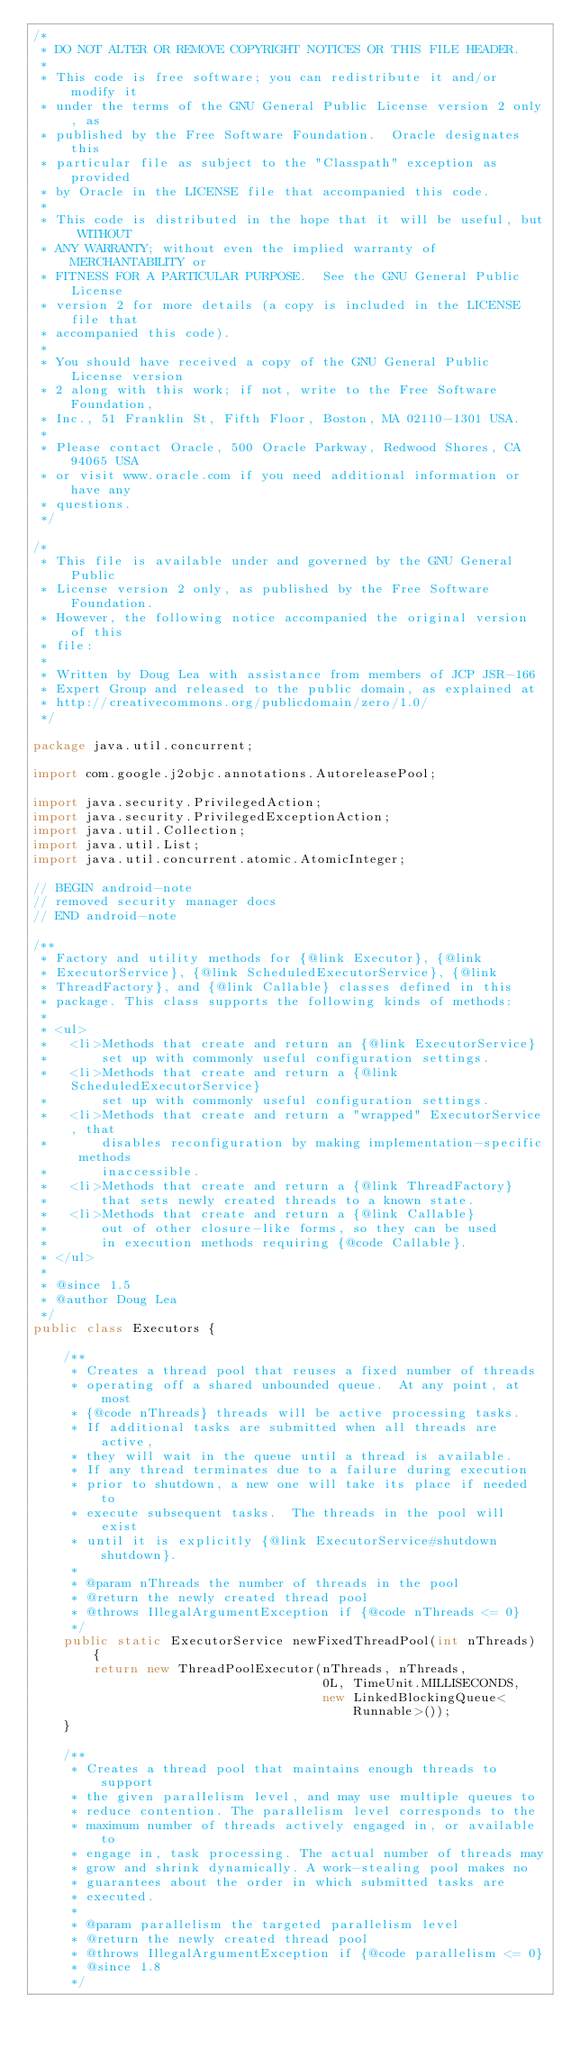Convert code to text. <code><loc_0><loc_0><loc_500><loc_500><_Java_>/*
 * DO NOT ALTER OR REMOVE COPYRIGHT NOTICES OR THIS FILE HEADER.
 *
 * This code is free software; you can redistribute it and/or modify it
 * under the terms of the GNU General Public License version 2 only, as
 * published by the Free Software Foundation.  Oracle designates this
 * particular file as subject to the "Classpath" exception as provided
 * by Oracle in the LICENSE file that accompanied this code.
 *
 * This code is distributed in the hope that it will be useful, but WITHOUT
 * ANY WARRANTY; without even the implied warranty of MERCHANTABILITY or
 * FITNESS FOR A PARTICULAR PURPOSE.  See the GNU General Public License
 * version 2 for more details (a copy is included in the LICENSE file that
 * accompanied this code).
 *
 * You should have received a copy of the GNU General Public License version
 * 2 along with this work; if not, write to the Free Software Foundation,
 * Inc., 51 Franklin St, Fifth Floor, Boston, MA 02110-1301 USA.
 *
 * Please contact Oracle, 500 Oracle Parkway, Redwood Shores, CA 94065 USA
 * or visit www.oracle.com if you need additional information or have any
 * questions.
 */

/*
 * This file is available under and governed by the GNU General Public
 * License version 2 only, as published by the Free Software Foundation.
 * However, the following notice accompanied the original version of this
 * file:
 *
 * Written by Doug Lea with assistance from members of JCP JSR-166
 * Expert Group and released to the public domain, as explained at
 * http://creativecommons.org/publicdomain/zero/1.0/
 */

package java.util.concurrent;

import com.google.j2objc.annotations.AutoreleasePool;

import java.security.PrivilegedAction;
import java.security.PrivilegedExceptionAction;
import java.util.Collection;
import java.util.List;
import java.util.concurrent.atomic.AtomicInteger;

// BEGIN android-note
// removed security manager docs
// END android-note

/**
 * Factory and utility methods for {@link Executor}, {@link
 * ExecutorService}, {@link ScheduledExecutorService}, {@link
 * ThreadFactory}, and {@link Callable} classes defined in this
 * package. This class supports the following kinds of methods:
 *
 * <ul>
 *   <li>Methods that create and return an {@link ExecutorService}
 *       set up with commonly useful configuration settings.
 *   <li>Methods that create and return a {@link ScheduledExecutorService}
 *       set up with commonly useful configuration settings.
 *   <li>Methods that create and return a "wrapped" ExecutorService, that
 *       disables reconfiguration by making implementation-specific methods
 *       inaccessible.
 *   <li>Methods that create and return a {@link ThreadFactory}
 *       that sets newly created threads to a known state.
 *   <li>Methods that create and return a {@link Callable}
 *       out of other closure-like forms, so they can be used
 *       in execution methods requiring {@code Callable}.
 * </ul>
 *
 * @since 1.5
 * @author Doug Lea
 */
public class Executors {

    /**
     * Creates a thread pool that reuses a fixed number of threads
     * operating off a shared unbounded queue.  At any point, at most
     * {@code nThreads} threads will be active processing tasks.
     * If additional tasks are submitted when all threads are active,
     * they will wait in the queue until a thread is available.
     * If any thread terminates due to a failure during execution
     * prior to shutdown, a new one will take its place if needed to
     * execute subsequent tasks.  The threads in the pool will exist
     * until it is explicitly {@link ExecutorService#shutdown shutdown}.
     *
     * @param nThreads the number of threads in the pool
     * @return the newly created thread pool
     * @throws IllegalArgumentException if {@code nThreads <= 0}
     */
    public static ExecutorService newFixedThreadPool(int nThreads) {
        return new ThreadPoolExecutor(nThreads, nThreads,
                                      0L, TimeUnit.MILLISECONDS,
                                      new LinkedBlockingQueue<Runnable>());
    }

    /**
     * Creates a thread pool that maintains enough threads to support
     * the given parallelism level, and may use multiple queues to
     * reduce contention. The parallelism level corresponds to the
     * maximum number of threads actively engaged in, or available to
     * engage in, task processing. The actual number of threads may
     * grow and shrink dynamically. A work-stealing pool makes no
     * guarantees about the order in which submitted tasks are
     * executed.
     *
     * @param parallelism the targeted parallelism level
     * @return the newly created thread pool
     * @throws IllegalArgumentException if {@code parallelism <= 0}
     * @since 1.8
     */</code> 